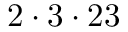Convert formula to latex. <formula><loc_0><loc_0><loc_500><loc_500>2 \cdot 3 \cdot 2 3</formula> 